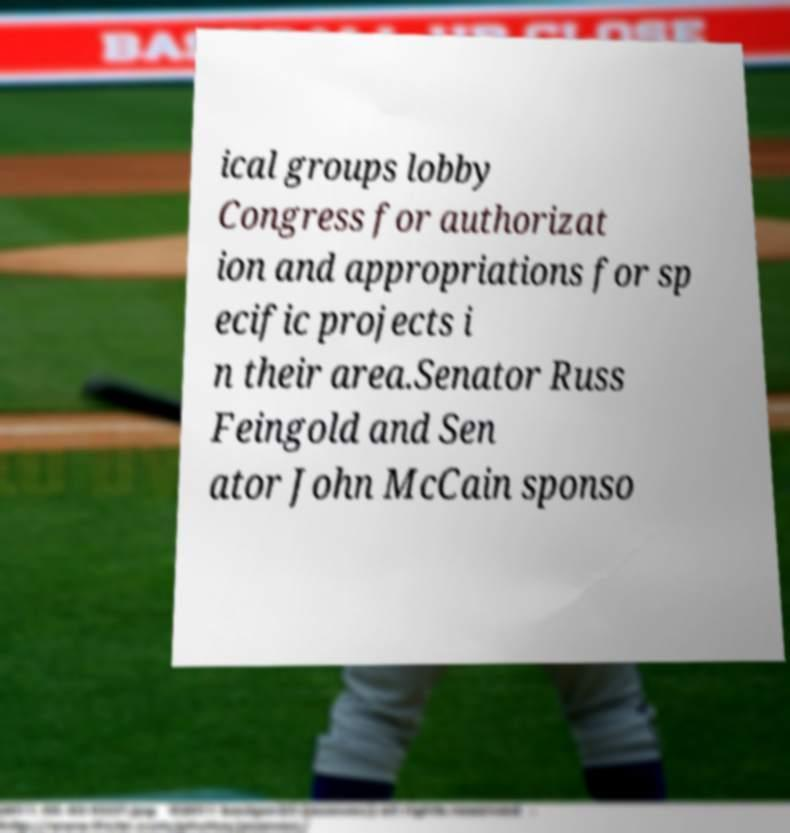Can you accurately transcribe the text from the provided image for me? ical groups lobby Congress for authorizat ion and appropriations for sp ecific projects i n their area.Senator Russ Feingold and Sen ator John McCain sponso 